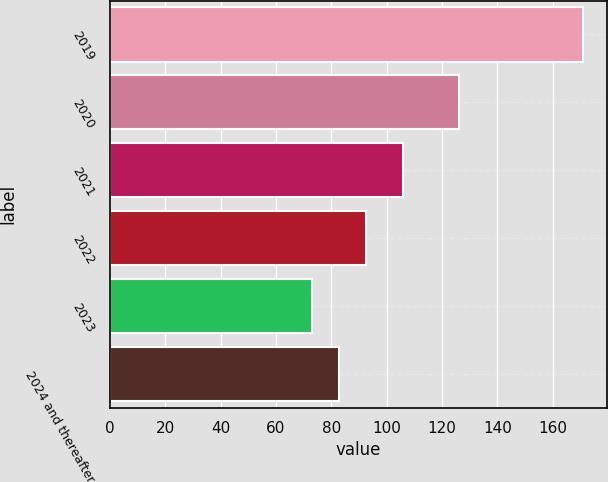<chart> <loc_0><loc_0><loc_500><loc_500><bar_chart><fcel>2019<fcel>2020<fcel>2021<fcel>2022<fcel>2023<fcel>2024 and thereafter<nl><fcel>171<fcel>126<fcel>106<fcel>92.6<fcel>73<fcel>82.8<nl></chart> 